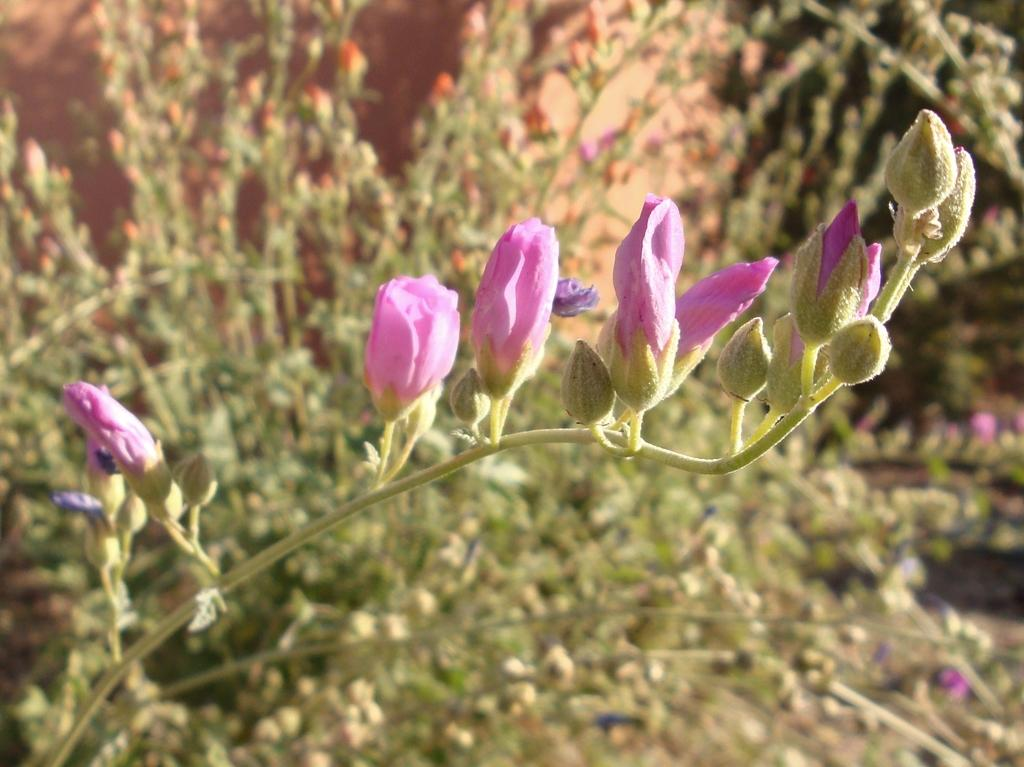What type of objects are present in the image with stems? There are flowers with stems in the image. Can you describe the background of the image? The background has a blurred view. What else can be seen in the image besides the flowers? There are plants visible in the image. What type of rail can be seen in the image? There is no rail present in the image; it features flowers with stems and plants in a blurred background. 